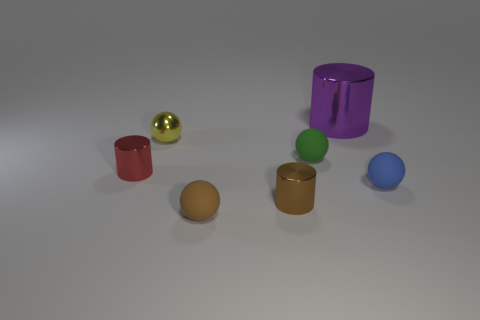Does the cylinder behind the red cylinder have the same size as the blue sphere?
Ensure brevity in your answer.  No. How many things are spheres on the left side of the large purple cylinder or cylinders in front of the tiny red object?
Keep it short and to the point. 4. What number of matte objects are small blue cylinders or small red things?
Provide a short and direct response. 0. The large purple metallic object is what shape?
Give a very brief answer. Cylinder. Are the blue sphere and the tiny green sphere made of the same material?
Provide a succinct answer. Yes. Are there any purple metal cylinders that are in front of the sphere in front of the tiny matte object right of the big purple cylinder?
Keep it short and to the point. No. What number of other objects are the same shape as the large purple object?
Offer a terse response. 2. What is the shape of the matte object that is to the left of the large cylinder and in front of the green sphere?
Your answer should be very brief. Sphere. The tiny metal cylinder to the right of the small ball that is to the left of the tiny rubber sphere that is in front of the tiny blue thing is what color?
Provide a succinct answer. Brown. Is the number of brown matte spheres that are to the right of the tiny green ball greater than the number of small blue balls that are behind the tiny blue matte thing?
Make the answer very short. No. 